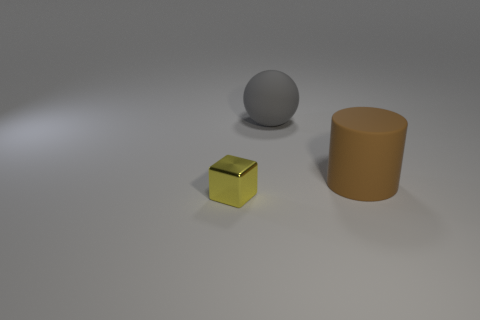Add 3 small metallic blocks. How many objects exist? 6 Subtract all spheres. How many objects are left? 2 Subtract all red blocks. Subtract all gray cylinders. How many blocks are left? 1 Subtract all brown matte cylinders. Subtract all yellow cubes. How many objects are left? 1 Add 1 brown cylinders. How many brown cylinders are left? 2 Add 2 cubes. How many cubes exist? 3 Subtract 0 purple blocks. How many objects are left? 3 Subtract 1 cubes. How many cubes are left? 0 